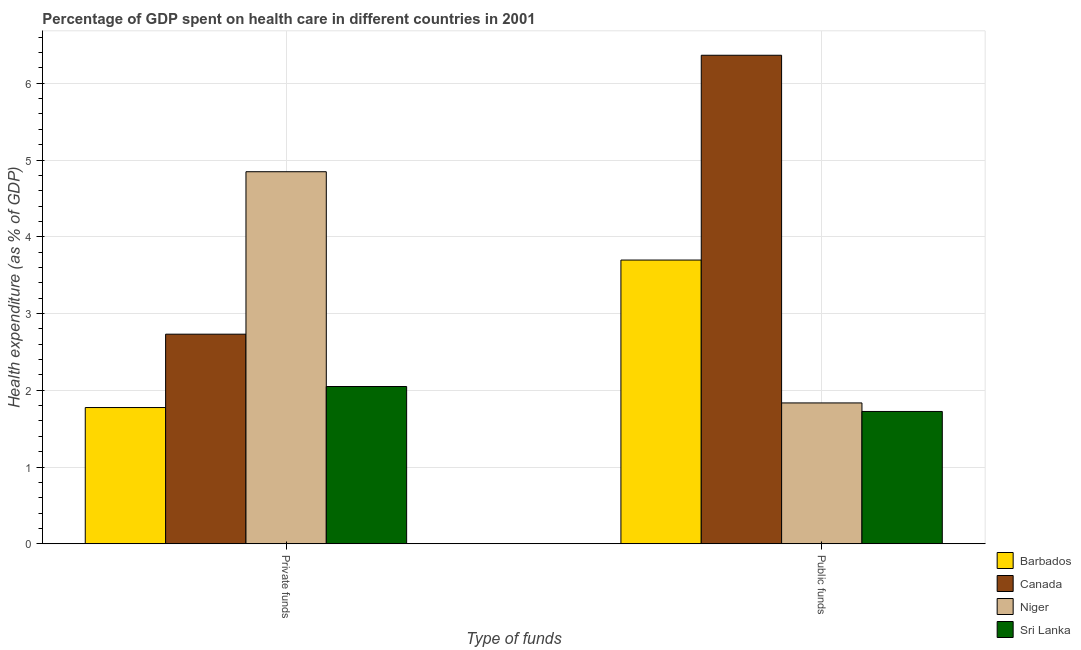Are the number of bars per tick equal to the number of legend labels?
Ensure brevity in your answer.  Yes. Are the number of bars on each tick of the X-axis equal?
Keep it short and to the point. Yes. How many bars are there on the 2nd tick from the left?
Keep it short and to the point. 4. How many bars are there on the 1st tick from the right?
Your response must be concise. 4. What is the label of the 1st group of bars from the left?
Your answer should be compact. Private funds. What is the amount of public funds spent in healthcare in Canada?
Make the answer very short. 6.36. Across all countries, what is the maximum amount of public funds spent in healthcare?
Give a very brief answer. 6.36. Across all countries, what is the minimum amount of public funds spent in healthcare?
Offer a terse response. 1.72. In which country was the amount of private funds spent in healthcare maximum?
Your response must be concise. Niger. In which country was the amount of private funds spent in healthcare minimum?
Provide a succinct answer. Barbados. What is the total amount of public funds spent in healthcare in the graph?
Your answer should be very brief. 13.62. What is the difference between the amount of private funds spent in healthcare in Canada and that in Barbados?
Keep it short and to the point. 0.96. What is the difference between the amount of private funds spent in healthcare in Canada and the amount of public funds spent in healthcare in Niger?
Ensure brevity in your answer.  0.9. What is the average amount of public funds spent in healthcare per country?
Make the answer very short. 3.41. What is the difference between the amount of private funds spent in healthcare and amount of public funds spent in healthcare in Sri Lanka?
Your response must be concise. 0.32. What is the ratio of the amount of private funds spent in healthcare in Canada to that in Sri Lanka?
Your answer should be compact. 1.33. Is the amount of private funds spent in healthcare in Sri Lanka less than that in Niger?
Your response must be concise. Yes. In how many countries, is the amount of private funds spent in healthcare greater than the average amount of private funds spent in healthcare taken over all countries?
Offer a very short reply. 1. What does the 4th bar from the left in Private funds represents?
Make the answer very short. Sri Lanka. What does the 4th bar from the right in Public funds represents?
Your response must be concise. Barbados. How many bars are there?
Make the answer very short. 8. Are all the bars in the graph horizontal?
Give a very brief answer. No. Are the values on the major ticks of Y-axis written in scientific E-notation?
Your answer should be compact. No. Does the graph contain any zero values?
Keep it short and to the point. No. Does the graph contain grids?
Make the answer very short. Yes. What is the title of the graph?
Your response must be concise. Percentage of GDP spent on health care in different countries in 2001. What is the label or title of the X-axis?
Provide a succinct answer. Type of funds. What is the label or title of the Y-axis?
Ensure brevity in your answer.  Health expenditure (as % of GDP). What is the Health expenditure (as % of GDP) in Barbados in Private funds?
Make the answer very short. 1.78. What is the Health expenditure (as % of GDP) in Canada in Private funds?
Give a very brief answer. 2.73. What is the Health expenditure (as % of GDP) of Niger in Private funds?
Make the answer very short. 4.85. What is the Health expenditure (as % of GDP) in Sri Lanka in Private funds?
Ensure brevity in your answer.  2.05. What is the Health expenditure (as % of GDP) in Barbados in Public funds?
Your response must be concise. 3.7. What is the Health expenditure (as % of GDP) of Canada in Public funds?
Ensure brevity in your answer.  6.36. What is the Health expenditure (as % of GDP) in Niger in Public funds?
Make the answer very short. 1.84. What is the Health expenditure (as % of GDP) in Sri Lanka in Public funds?
Keep it short and to the point. 1.72. Across all Type of funds, what is the maximum Health expenditure (as % of GDP) of Barbados?
Your answer should be very brief. 3.7. Across all Type of funds, what is the maximum Health expenditure (as % of GDP) in Canada?
Provide a succinct answer. 6.36. Across all Type of funds, what is the maximum Health expenditure (as % of GDP) in Niger?
Your answer should be very brief. 4.85. Across all Type of funds, what is the maximum Health expenditure (as % of GDP) in Sri Lanka?
Offer a terse response. 2.05. Across all Type of funds, what is the minimum Health expenditure (as % of GDP) in Barbados?
Offer a very short reply. 1.78. Across all Type of funds, what is the minimum Health expenditure (as % of GDP) of Canada?
Provide a short and direct response. 2.73. Across all Type of funds, what is the minimum Health expenditure (as % of GDP) of Niger?
Your response must be concise. 1.84. Across all Type of funds, what is the minimum Health expenditure (as % of GDP) of Sri Lanka?
Ensure brevity in your answer.  1.72. What is the total Health expenditure (as % of GDP) of Barbados in the graph?
Offer a terse response. 5.47. What is the total Health expenditure (as % of GDP) in Canada in the graph?
Your response must be concise. 9.1. What is the total Health expenditure (as % of GDP) in Niger in the graph?
Make the answer very short. 6.68. What is the total Health expenditure (as % of GDP) of Sri Lanka in the graph?
Your answer should be compact. 3.77. What is the difference between the Health expenditure (as % of GDP) in Barbados in Private funds and that in Public funds?
Offer a terse response. -1.92. What is the difference between the Health expenditure (as % of GDP) in Canada in Private funds and that in Public funds?
Give a very brief answer. -3.63. What is the difference between the Health expenditure (as % of GDP) in Niger in Private funds and that in Public funds?
Make the answer very short. 3.01. What is the difference between the Health expenditure (as % of GDP) of Sri Lanka in Private funds and that in Public funds?
Provide a succinct answer. 0.33. What is the difference between the Health expenditure (as % of GDP) of Barbados in Private funds and the Health expenditure (as % of GDP) of Canada in Public funds?
Offer a very short reply. -4.59. What is the difference between the Health expenditure (as % of GDP) in Barbados in Private funds and the Health expenditure (as % of GDP) in Niger in Public funds?
Your answer should be compact. -0.06. What is the difference between the Health expenditure (as % of GDP) of Barbados in Private funds and the Health expenditure (as % of GDP) of Sri Lanka in Public funds?
Ensure brevity in your answer.  0.05. What is the difference between the Health expenditure (as % of GDP) in Canada in Private funds and the Health expenditure (as % of GDP) in Niger in Public funds?
Make the answer very short. 0.9. What is the difference between the Health expenditure (as % of GDP) in Canada in Private funds and the Health expenditure (as % of GDP) in Sri Lanka in Public funds?
Ensure brevity in your answer.  1.01. What is the difference between the Health expenditure (as % of GDP) of Niger in Private funds and the Health expenditure (as % of GDP) of Sri Lanka in Public funds?
Your answer should be compact. 3.12. What is the average Health expenditure (as % of GDP) of Barbados per Type of funds?
Provide a short and direct response. 2.74. What is the average Health expenditure (as % of GDP) in Canada per Type of funds?
Offer a terse response. 4.55. What is the average Health expenditure (as % of GDP) in Niger per Type of funds?
Your response must be concise. 3.34. What is the average Health expenditure (as % of GDP) in Sri Lanka per Type of funds?
Provide a succinct answer. 1.89. What is the difference between the Health expenditure (as % of GDP) of Barbados and Health expenditure (as % of GDP) of Canada in Private funds?
Offer a very short reply. -0.96. What is the difference between the Health expenditure (as % of GDP) of Barbados and Health expenditure (as % of GDP) of Niger in Private funds?
Your answer should be very brief. -3.07. What is the difference between the Health expenditure (as % of GDP) in Barbados and Health expenditure (as % of GDP) in Sri Lanka in Private funds?
Your response must be concise. -0.27. What is the difference between the Health expenditure (as % of GDP) of Canada and Health expenditure (as % of GDP) of Niger in Private funds?
Give a very brief answer. -2.12. What is the difference between the Health expenditure (as % of GDP) of Canada and Health expenditure (as % of GDP) of Sri Lanka in Private funds?
Give a very brief answer. 0.68. What is the difference between the Health expenditure (as % of GDP) in Niger and Health expenditure (as % of GDP) in Sri Lanka in Private funds?
Keep it short and to the point. 2.8. What is the difference between the Health expenditure (as % of GDP) in Barbados and Health expenditure (as % of GDP) in Canada in Public funds?
Offer a terse response. -2.67. What is the difference between the Health expenditure (as % of GDP) of Barbados and Health expenditure (as % of GDP) of Niger in Public funds?
Offer a terse response. 1.86. What is the difference between the Health expenditure (as % of GDP) of Barbados and Health expenditure (as % of GDP) of Sri Lanka in Public funds?
Offer a terse response. 1.97. What is the difference between the Health expenditure (as % of GDP) in Canada and Health expenditure (as % of GDP) in Niger in Public funds?
Offer a terse response. 4.53. What is the difference between the Health expenditure (as % of GDP) of Canada and Health expenditure (as % of GDP) of Sri Lanka in Public funds?
Your answer should be very brief. 4.64. What is the difference between the Health expenditure (as % of GDP) in Niger and Health expenditure (as % of GDP) in Sri Lanka in Public funds?
Offer a terse response. 0.11. What is the ratio of the Health expenditure (as % of GDP) of Barbados in Private funds to that in Public funds?
Give a very brief answer. 0.48. What is the ratio of the Health expenditure (as % of GDP) in Canada in Private funds to that in Public funds?
Make the answer very short. 0.43. What is the ratio of the Health expenditure (as % of GDP) of Niger in Private funds to that in Public funds?
Your answer should be compact. 2.64. What is the ratio of the Health expenditure (as % of GDP) of Sri Lanka in Private funds to that in Public funds?
Keep it short and to the point. 1.19. What is the difference between the highest and the second highest Health expenditure (as % of GDP) of Barbados?
Offer a very short reply. 1.92. What is the difference between the highest and the second highest Health expenditure (as % of GDP) in Canada?
Your answer should be compact. 3.63. What is the difference between the highest and the second highest Health expenditure (as % of GDP) of Niger?
Ensure brevity in your answer.  3.01. What is the difference between the highest and the second highest Health expenditure (as % of GDP) in Sri Lanka?
Make the answer very short. 0.33. What is the difference between the highest and the lowest Health expenditure (as % of GDP) of Barbados?
Provide a short and direct response. 1.92. What is the difference between the highest and the lowest Health expenditure (as % of GDP) of Canada?
Your response must be concise. 3.63. What is the difference between the highest and the lowest Health expenditure (as % of GDP) in Niger?
Provide a short and direct response. 3.01. What is the difference between the highest and the lowest Health expenditure (as % of GDP) in Sri Lanka?
Your answer should be very brief. 0.33. 